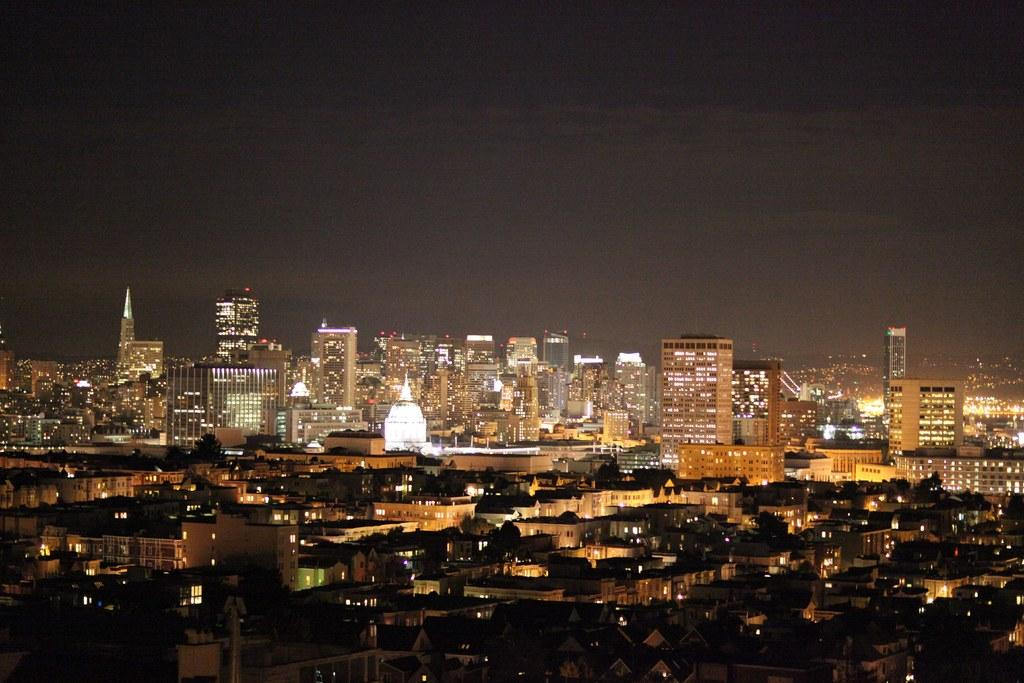What perspective is the image taken from? The image is taken from a top view. What type of structures can be seen in the image? There are buildings and skyscrapers in the image. What are the light poles used for in the image? The light poles are likely used for illuminating the area at night. What is visible at the top of the image? The sky is visible at the top of the image. Can you see a pancake being flipped on a griddle in the image? No, there is no pancake or griddle present in the image. What type of rabbit can be seen hopping between the buildings in the image? There are no rabbits visible in the image; it features buildings, skyscrapers, light poles, and the sky. 